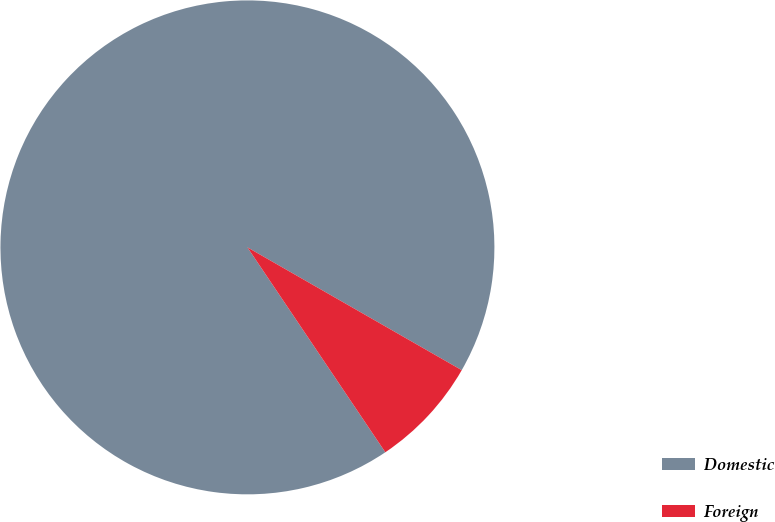<chart> <loc_0><loc_0><loc_500><loc_500><pie_chart><fcel>Domestic<fcel>Foreign<nl><fcel>92.71%<fcel>7.29%<nl></chart> 